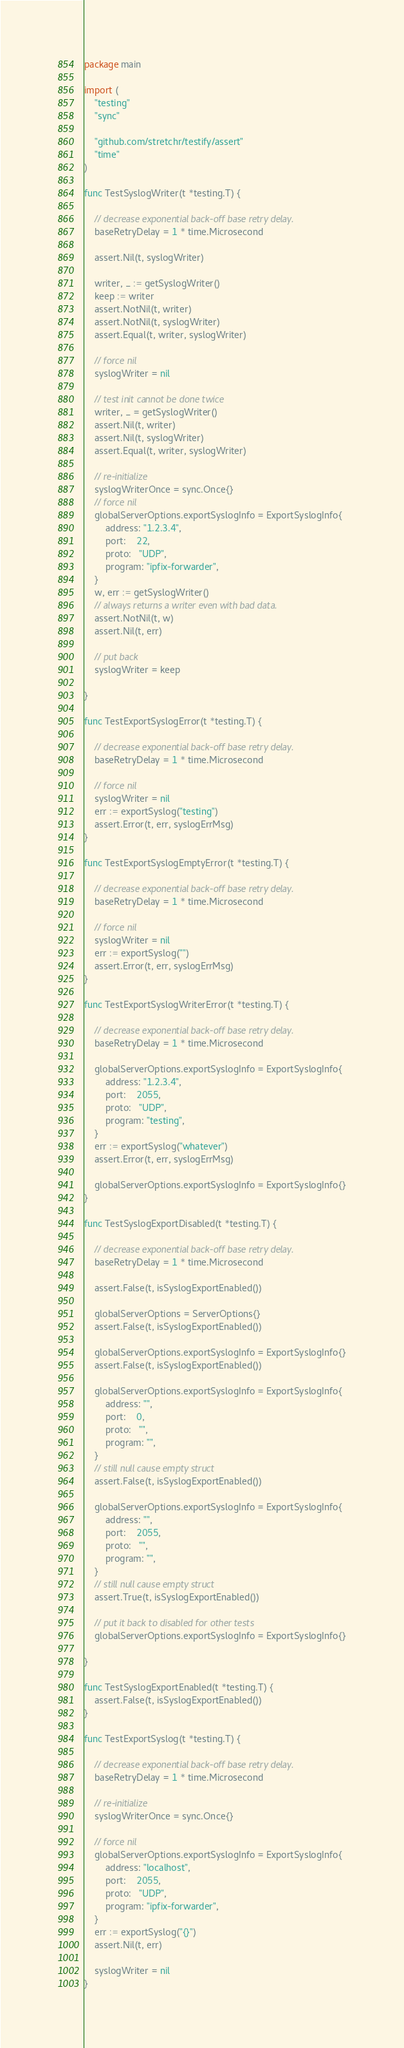<code> <loc_0><loc_0><loc_500><loc_500><_Go_>package main

import (
	"testing"
	"sync"

	"github.com/stretchr/testify/assert"
	"time"
)

func TestSyslogWriter(t *testing.T) {

	// decrease exponential back-off base retry delay.
	baseRetryDelay = 1 * time.Microsecond

	assert.Nil(t, syslogWriter)

	writer, _ := getSyslogWriter()
	keep := writer
	assert.NotNil(t, writer)
	assert.NotNil(t, syslogWriter)
	assert.Equal(t, writer, syslogWriter)

	// force nil
	syslogWriter = nil

	// test init cannot be done twice
	writer, _ = getSyslogWriter()
	assert.Nil(t, writer)
	assert.Nil(t, syslogWriter)
	assert.Equal(t, writer, syslogWriter)

	// re-initialize
	syslogWriterOnce = sync.Once{}
	// force nil
	globalServerOptions.exportSyslogInfo = ExportSyslogInfo{
		address: "1.2.3.4",
		port:    22,
		proto:   "UDP",
		program: "ipfix-forwarder",
	}
	w, err := getSyslogWriter()
	// always returns a writer even with bad data.
	assert.NotNil(t, w)
	assert.Nil(t, err)

	// put back
	syslogWriter = keep

}

func TestExportSyslogError(t *testing.T) {

	// decrease exponential back-off base retry delay.
	baseRetryDelay = 1 * time.Microsecond

	// force nil
	syslogWriter = nil
	err := exportSyslog("testing")
	assert.Error(t, err, syslogErrMsg)
}

func TestExportSyslogEmptyError(t *testing.T) {

	// decrease exponential back-off base retry delay.
	baseRetryDelay = 1 * time.Microsecond

	// force nil
	syslogWriter = nil
	err := exportSyslog("")
	assert.Error(t, err, syslogErrMsg)
}

func TestExportSyslogWriterError(t *testing.T) {

	// decrease exponential back-off base retry delay.
	baseRetryDelay = 1 * time.Microsecond

	globalServerOptions.exportSyslogInfo = ExportSyslogInfo{
		address: "1.2.3.4",
		port:    2055,
		proto:   "UDP",
		program: "testing",
	}
	err := exportSyslog("whatever")
	assert.Error(t, err, syslogErrMsg)

	globalServerOptions.exportSyslogInfo = ExportSyslogInfo{}
}

func TestSyslogExportDisabled(t *testing.T) {

	// decrease exponential back-off base retry delay.
	baseRetryDelay = 1 * time.Microsecond

	assert.False(t, isSyslogExportEnabled())

	globalServerOptions = ServerOptions{}
	assert.False(t, isSyslogExportEnabled())

	globalServerOptions.exportSyslogInfo = ExportSyslogInfo{}
	assert.False(t, isSyslogExportEnabled())

	globalServerOptions.exportSyslogInfo = ExportSyslogInfo{
		address: "",
		port:    0,
		proto:   "",
		program: "",
	}
	// still null cause empty struct
	assert.False(t, isSyslogExportEnabled())

	globalServerOptions.exportSyslogInfo = ExportSyslogInfo{
		address: "",
		port:    2055,
		proto:   "",
		program: "",
	}
	// still null cause empty struct
	assert.True(t, isSyslogExportEnabled())

	// put it back to disabled for other tests
	globalServerOptions.exportSyslogInfo = ExportSyslogInfo{}

}

func TestSyslogExportEnabled(t *testing.T) {
	assert.False(t, isSyslogExportEnabled())
}

func TestExportSyslog(t *testing.T) {

	// decrease exponential back-off base retry delay.
	baseRetryDelay = 1 * time.Microsecond

	// re-initialize
	syslogWriterOnce = sync.Once{}

	// force nil
	globalServerOptions.exportSyslogInfo = ExportSyslogInfo{
		address: "localhost",
		port:    2055,
		proto:   "UDP",
		program: "ipfix-forwarder",
	}
	err := exportSyslog("{}")
	assert.Nil(t, err)

	syslogWriter = nil
}
</code> 